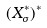<formula> <loc_0><loc_0><loc_500><loc_500>( X _ { \sigma } ^ { * } ) ^ { * }</formula> 